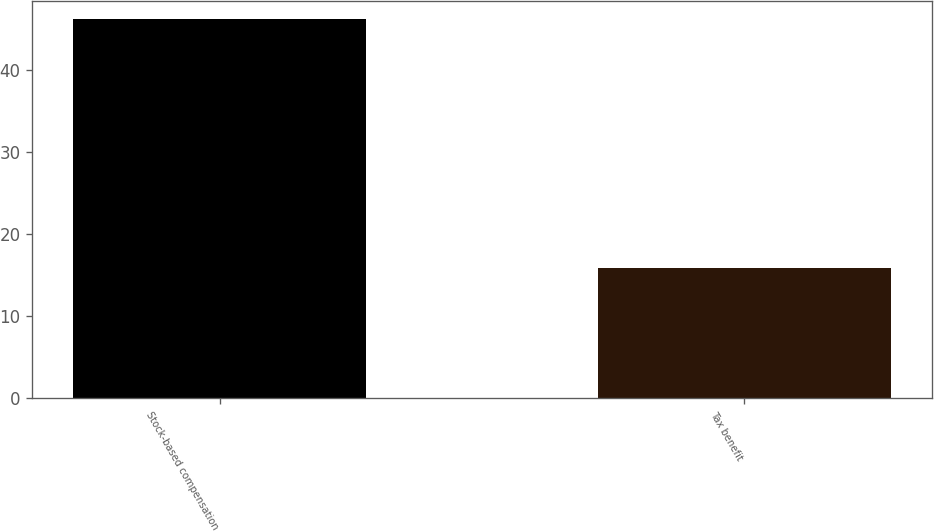<chart> <loc_0><loc_0><loc_500><loc_500><bar_chart><fcel>Stock-based compensation<fcel>Tax benefit<nl><fcel>46.1<fcel>15.9<nl></chart> 